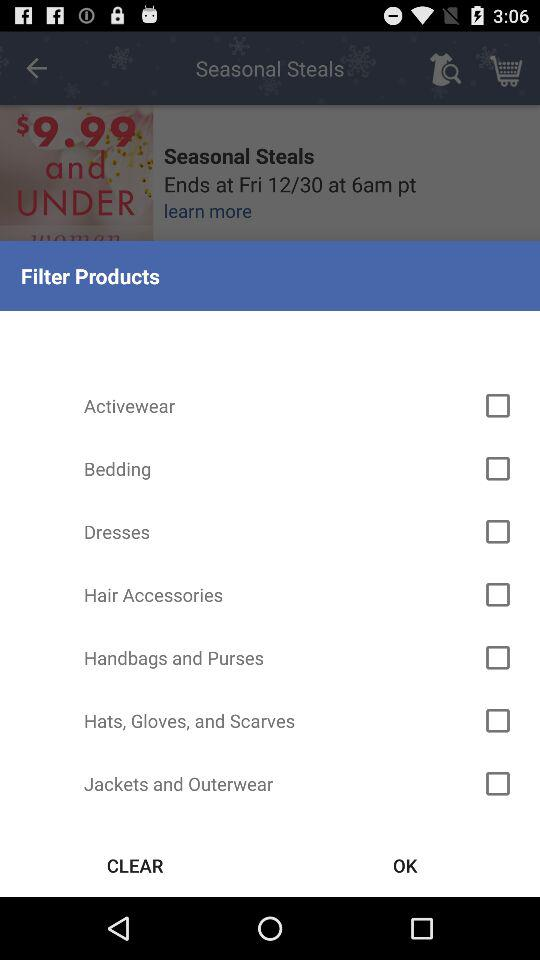Which options are unchecked? The options that are unchecked are "Activewear", "Bedding", "Dresses", "Hair Accessories", "Handbags and Purses", "Hats, Gloves, and Scarves" and "Jackets and Outerwear". 